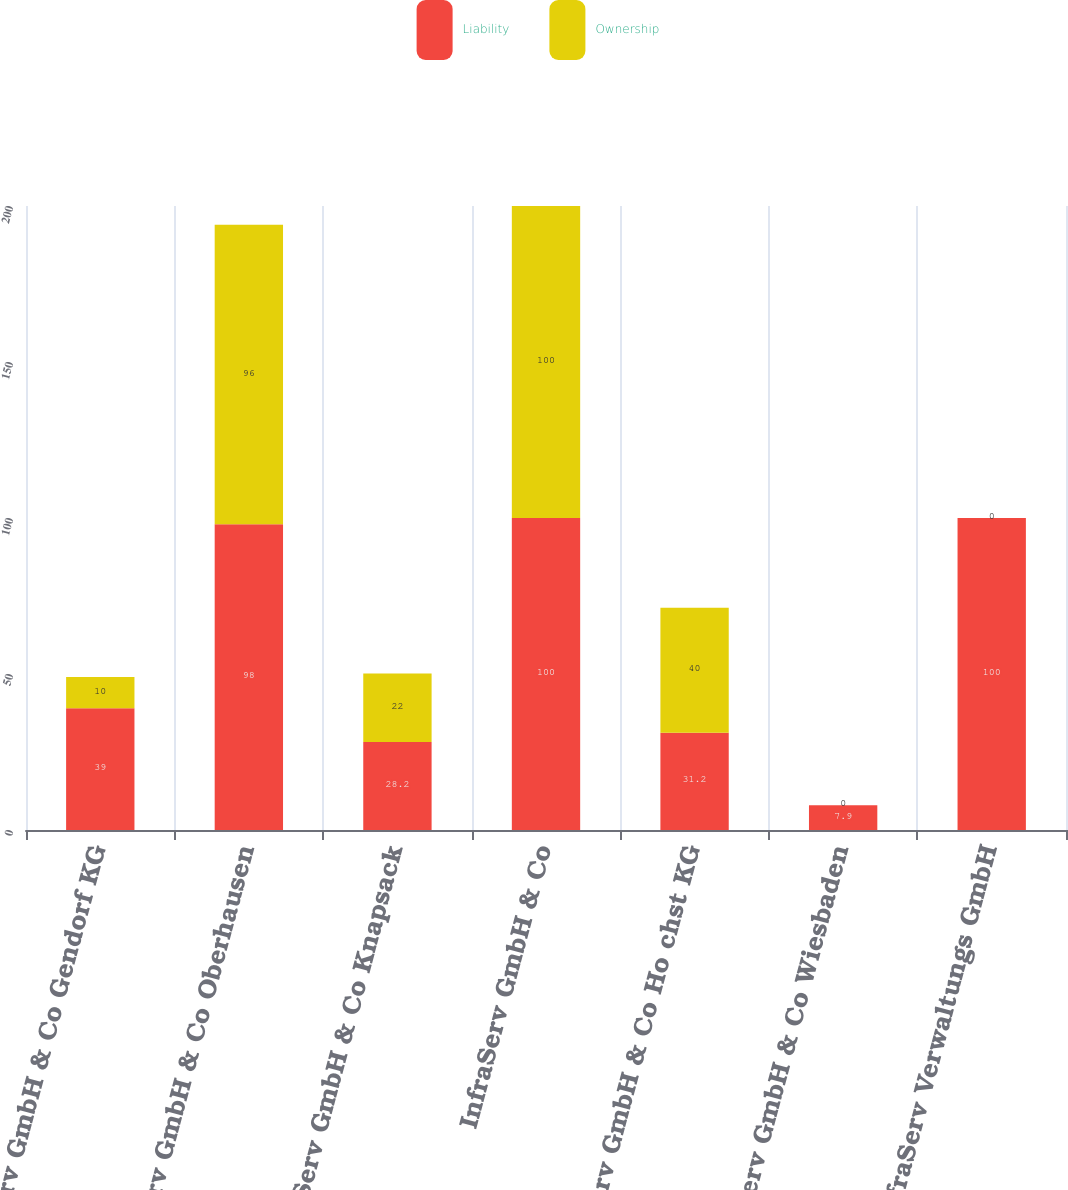Convert chart. <chart><loc_0><loc_0><loc_500><loc_500><stacked_bar_chart><ecel><fcel>InfraServ GmbH & Co Gendorf KG<fcel>InfraServ GmbH & Co Oberhausen<fcel>InfraServ GmbH & Co Knapsack<fcel>InfraServ GmbH & Co<fcel>InfraServ GmbH & Co Ho chst KG<fcel>InfraServ GmbH & Co Wiesbaden<fcel>InfraServ Verwaltungs GmbH<nl><fcel>Liability<fcel>39<fcel>98<fcel>28.2<fcel>100<fcel>31.2<fcel>7.9<fcel>100<nl><fcel>Ownership<fcel>10<fcel>96<fcel>22<fcel>100<fcel>40<fcel>0<fcel>0<nl></chart> 